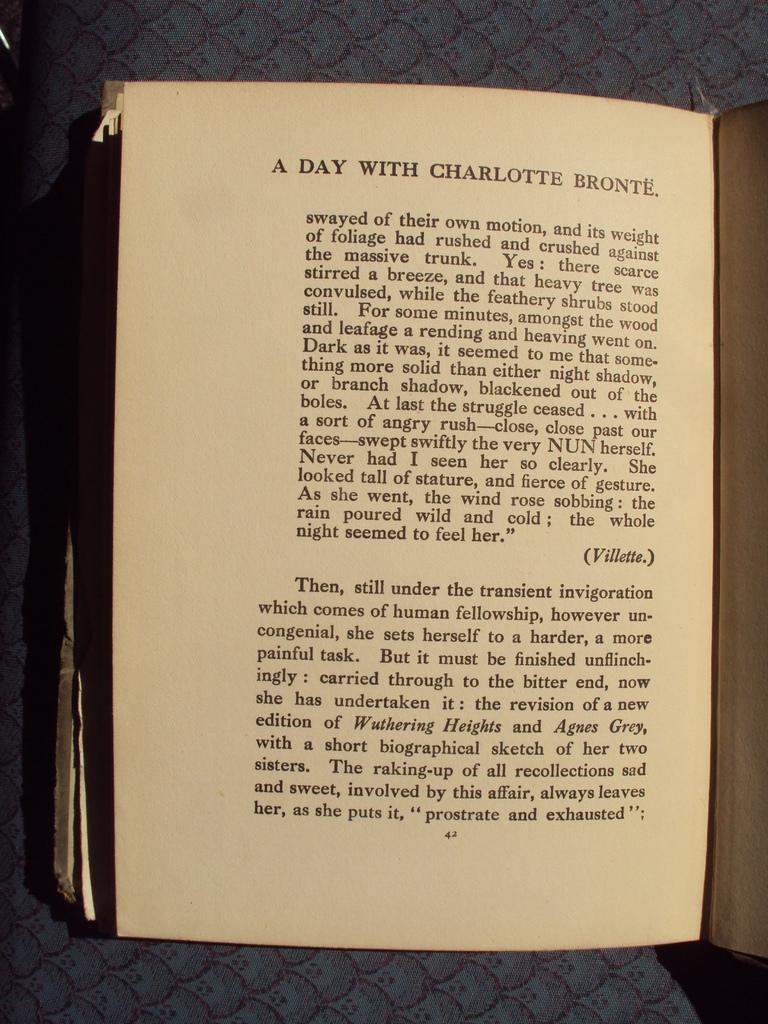Who is the day with?
Offer a very short reply. Charlotte bronte. 